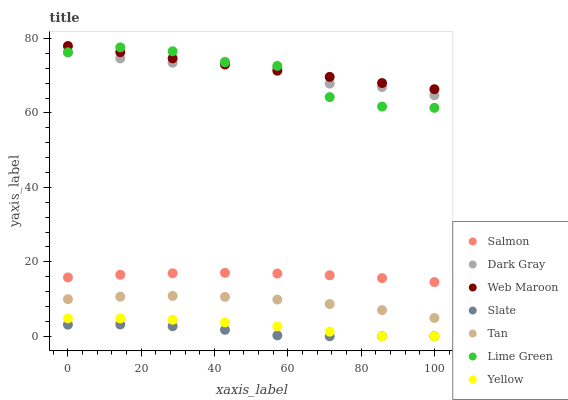Does Slate have the minimum area under the curve?
Answer yes or no. Yes. Does Web Maroon have the maximum area under the curve?
Answer yes or no. Yes. Does Web Maroon have the minimum area under the curve?
Answer yes or no. No. Does Slate have the maximum area under the curve?
Answer yes or no. No. Is Web Maroon the smoothest?
Answer yes or no. Yes. Is Lime Green the roughest?
Answer yes or no. Yes. Is Slate the smoothest?
Answer yes or no. No. Is Slate the roughest?
Answer yes or no. No. Does Slate have the lowest value?
Answer yes or no. Yes. Does Web Maroon have the lowest value?
Answer yes or no. No. Does Web Maroon have the highest value?
Answer yes or no. Yes. Does Slate have the highest value?
Answer yes or no. No. Is Yellow less than Salmon?
Answer yes or no. Yes. Is Tan greater than Yellow?
Answer yes or no. Yes. Does Web Maroon intersect Lime Green?
Answer yes or no. Yes. Is Web Maroon less than Lime Green?
Answer yes or no. No. Is Web Maroon greater than Lime Green?
Answer yes or no. No. Does Yellow intersect Salmon?
Answer yes or no. No. 